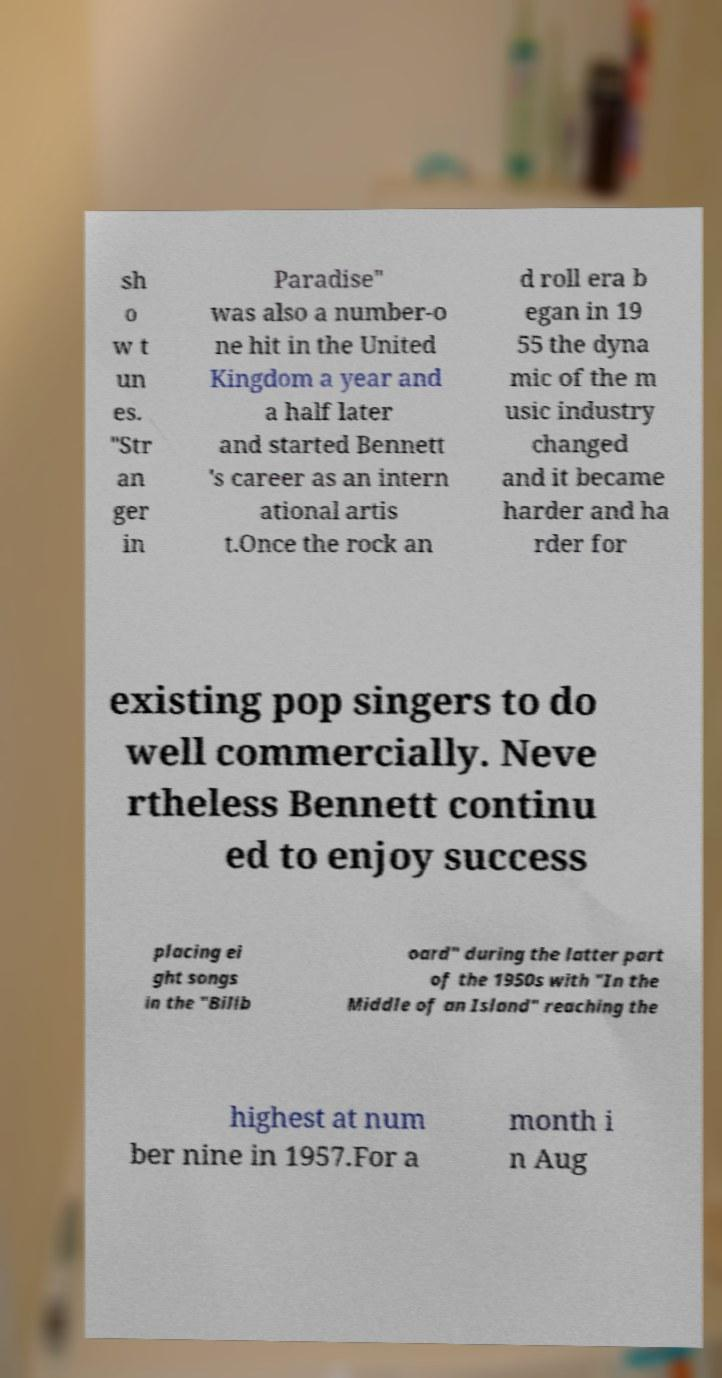What messages or text are displayed in this image? I need them in a readable, typed format. sh o w t un es. "Str an ger in Paradise" was also a number-o ne hit in the United Kingdom a year and a half later and started Bennett 's career as an intern ational artis t.Once the rock an d roll era b egan in 19 55 the dyna mic of the m usic industry changed and it became harder and ha rder for existing pop singers to do well commercially. Neve rtheless Bennett continu ed to enjoy success placing ei ght songs in the "Billb oard" during the latter part of the 1950s with "In the Middle of an Island" reaching the highest at num ber nine in 1957.For a month i n Aug 